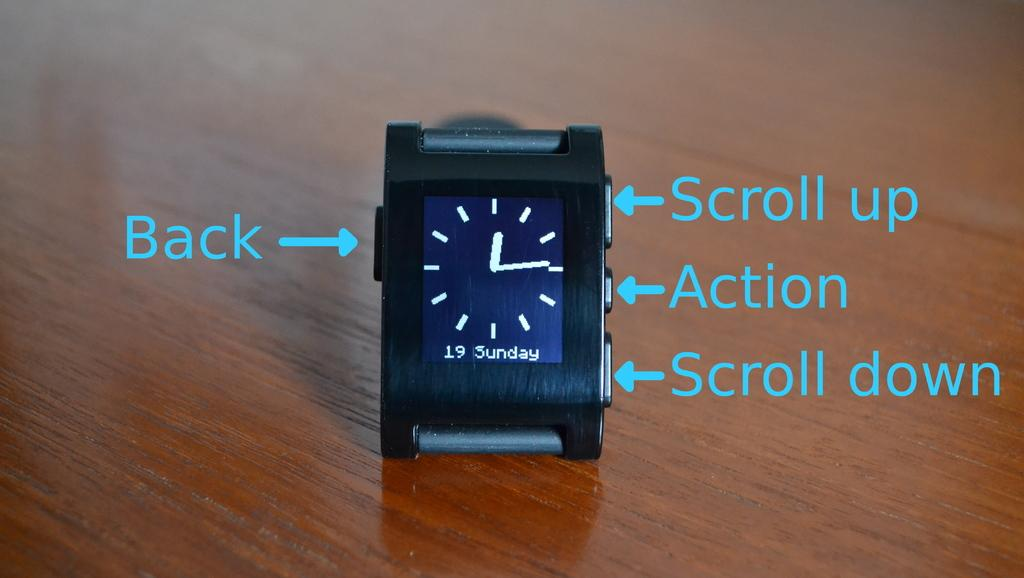<image>
Provide a brief description of the given image. Face of a clock which says Sunday on it. 